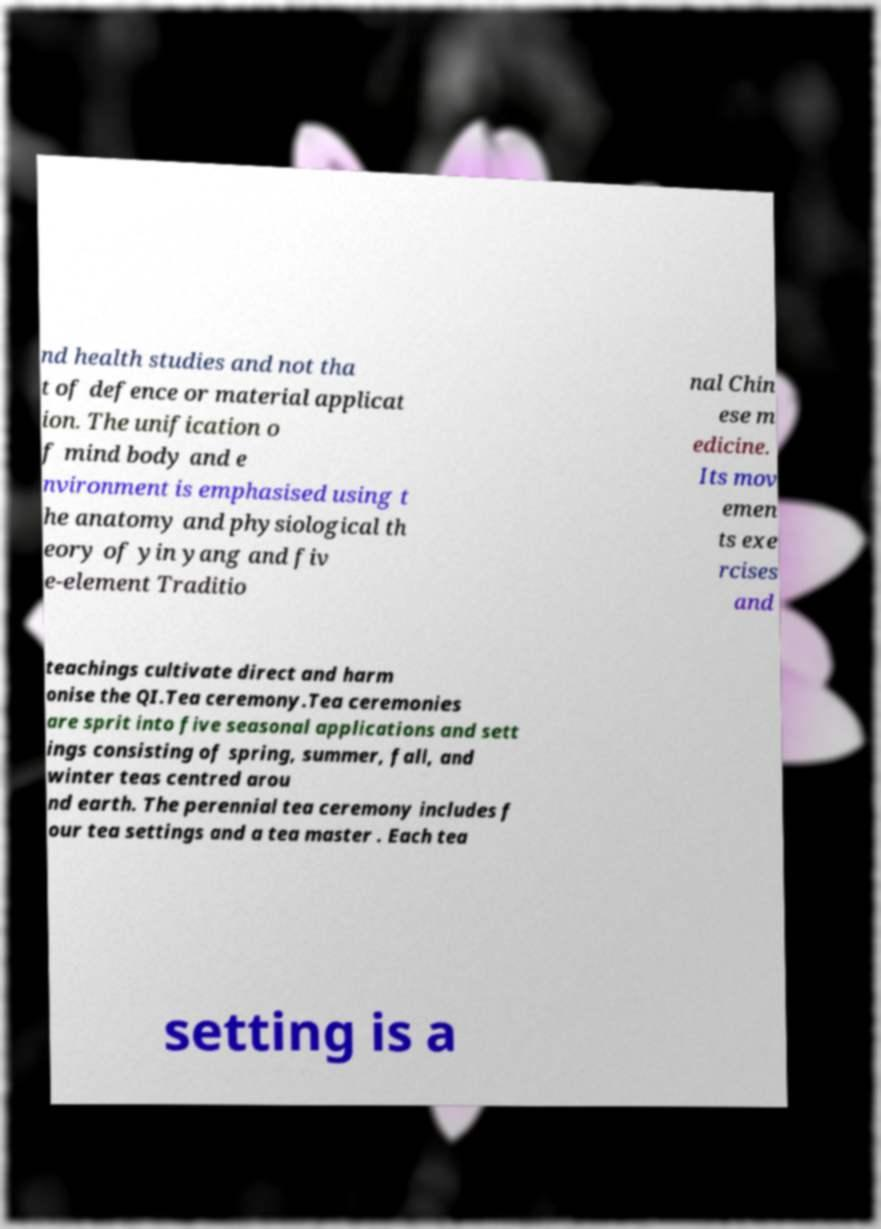For documentation purposes, I need the text within this image transcribed. Could you provide that? nd health studies and not tha t of defence or material applicat ion. The unification o f mind body and e nvironment is emphasised using t he anatomy and physiological th eory of yin yang and fiv e-element Traditio nal Chin ese m edicine. Its mov emen ts exe rcises and teachings cultivate direct and harm onise the QI.Tea ceremony.Tea ceremonies are sprit into five seasonal applications and sett ings consisting of spring, summer, fall, and winter teas centred arou nd earth. The perennial tea ceremony includes f our tea settings and a tea master . Each tea setting is a 